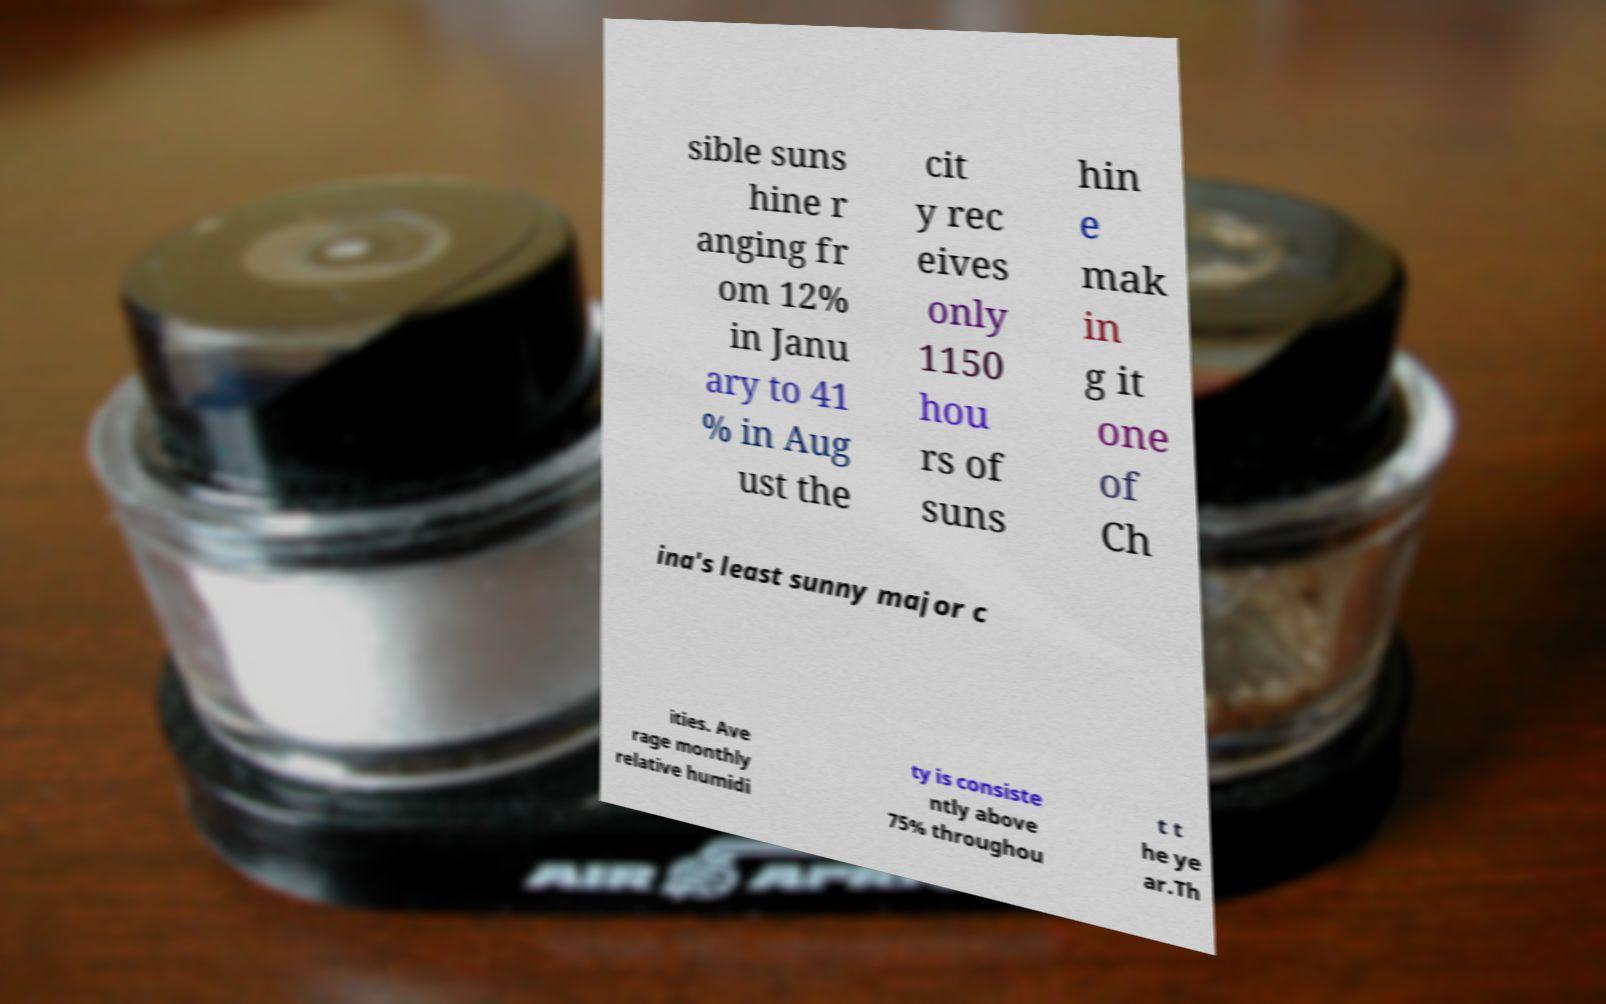Could you extract and type out the text from this image? sible suns hine r anging fr om 12% in Janu ary to 41 % in Aug ust the cit y rec eives only 1150 hou rs of suns hin e mak in g it one of Ch ina's least sunny major c ities. Ave rage monthly relative humidi ty is consiste ntly above 75% throughou t t he ye ar.Th 